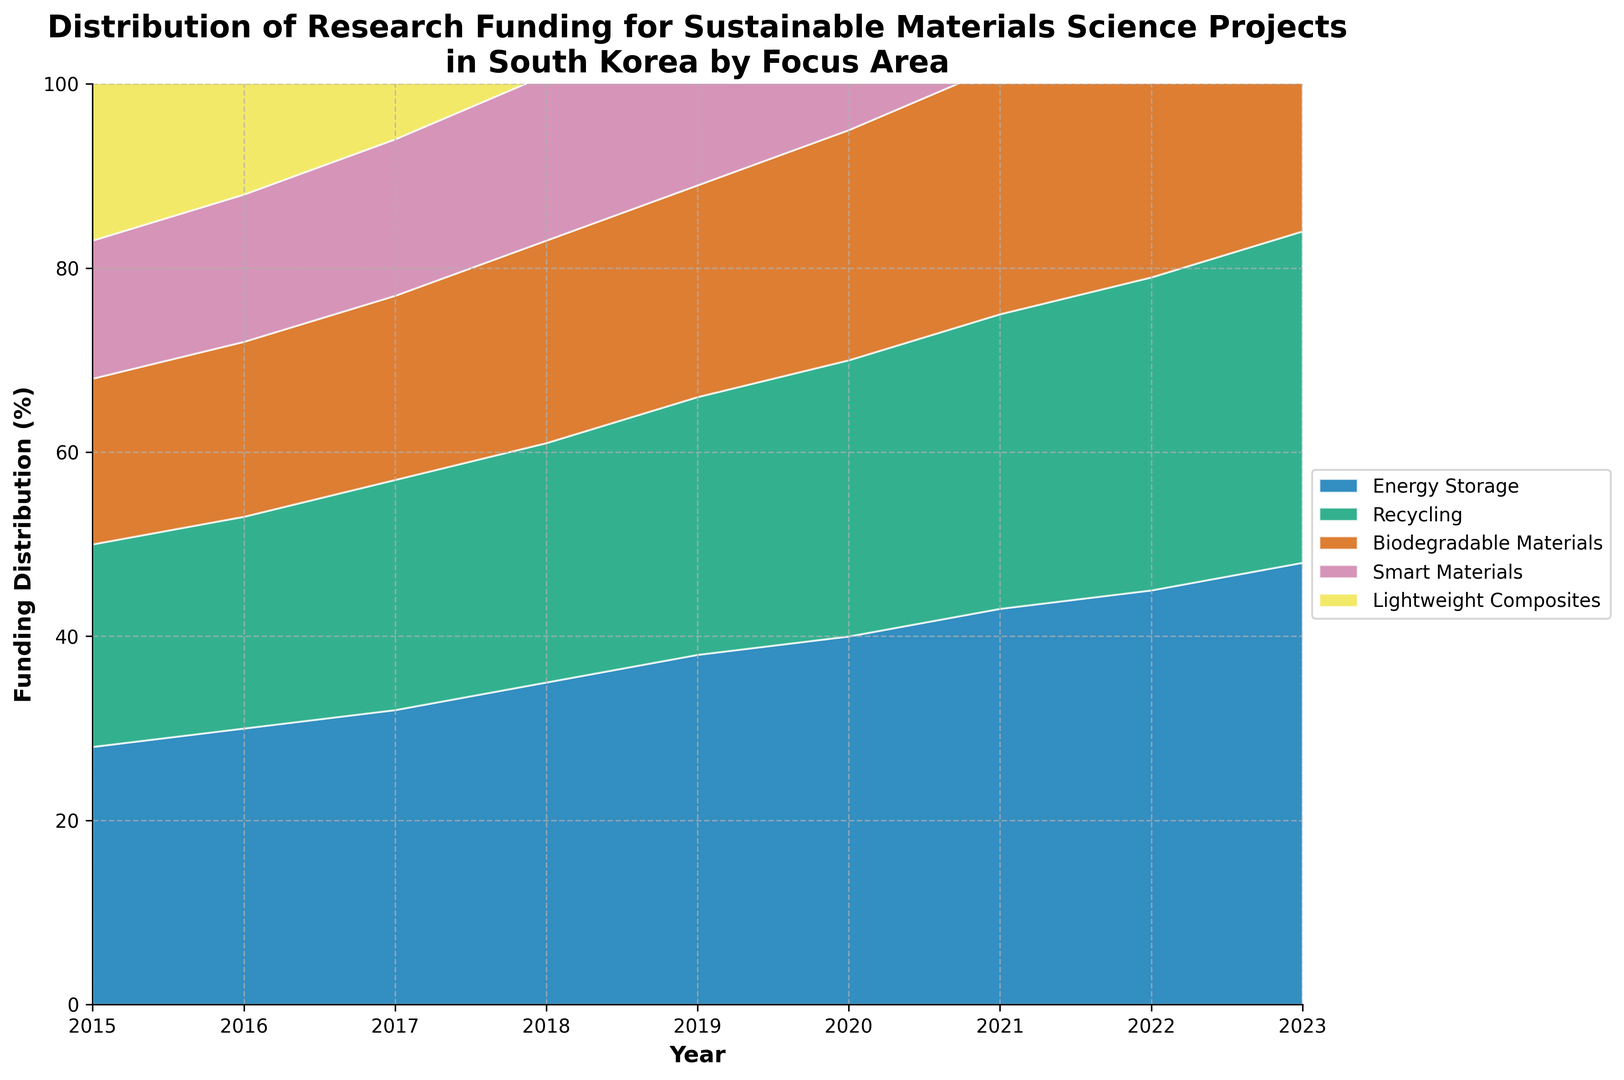what is the total funding percentage dedicated to "Recycling" projects in 2017? Look at the area corresponding to "Recycling" in the year 2017. The figure indicates the percentage is 25%.
Answer: 25% How does the funding for "Biodegradable Materials" in 2020 compare to 2015? In 2015, the funding for "Biodegradable Materials" is 18%. In 2020, it's 25%. The funding increased by 25% - 18% = 7 percentage points.
Answer: Increased by 7% Which focus area had the least funding in 2022? By examining the height of the colored areas in 2022, "Smart Materials" received the least funding, with a percentage of 22%.
Answer: Smart Materials What is the average funding percentage for "Energy Storage" over the years 2015 to 2023? Sum the percentages for "Energy Storage" from each year and divide by the number of years. (28+30+32+35+38+40+43+45+48)/9 = 339/9 = 37.67
Answer: 37.67% What is the combined funding percentage for "Lightweight Composites" and "Smart Materials" in 2021? Look at the funding percentages for "Lightweight Composites" and "Smart Materials" in 2021: 23% and 21% respectively. Combine them: 23% + 21% = 44%
Answer: 44% Which year showed the highest overall funding for "Energy Storage" projects? Examine the chart and identify the highest point of the "Energy Storage" area. The highest value is in 2023 with 48%.
Answer: 2023 Is the funding for "Recycling" always increasing over the years? Observe the chart for the funding trend of "Recycling" from 2015 to 2023. It consistently increases from 22% to 36%.
Answer: Yes What is the funding gap between "Lightweight Composites" and "Smart Materials" in 2019? Observe the percentages for "Lightweight Composites" (21%) and "Smart Materials" (19%) in 2019. The gap is 21% - 19% = 2 percentage points.
Answer: 2 percentage points Which focus area experienced the most significant increase in funding from 2015 to 2023? Compare the differences between 2023 and 2015 for all focus areas: Energy Storage (48-28=20), Recycling (36-22=14), Biodegradable Materials (31-18=13), Smart Materials (23-15=8), Lightweight Composites (25-17=8). "Energy Storage" has the most significant increase.
Answer: Energy Storage 